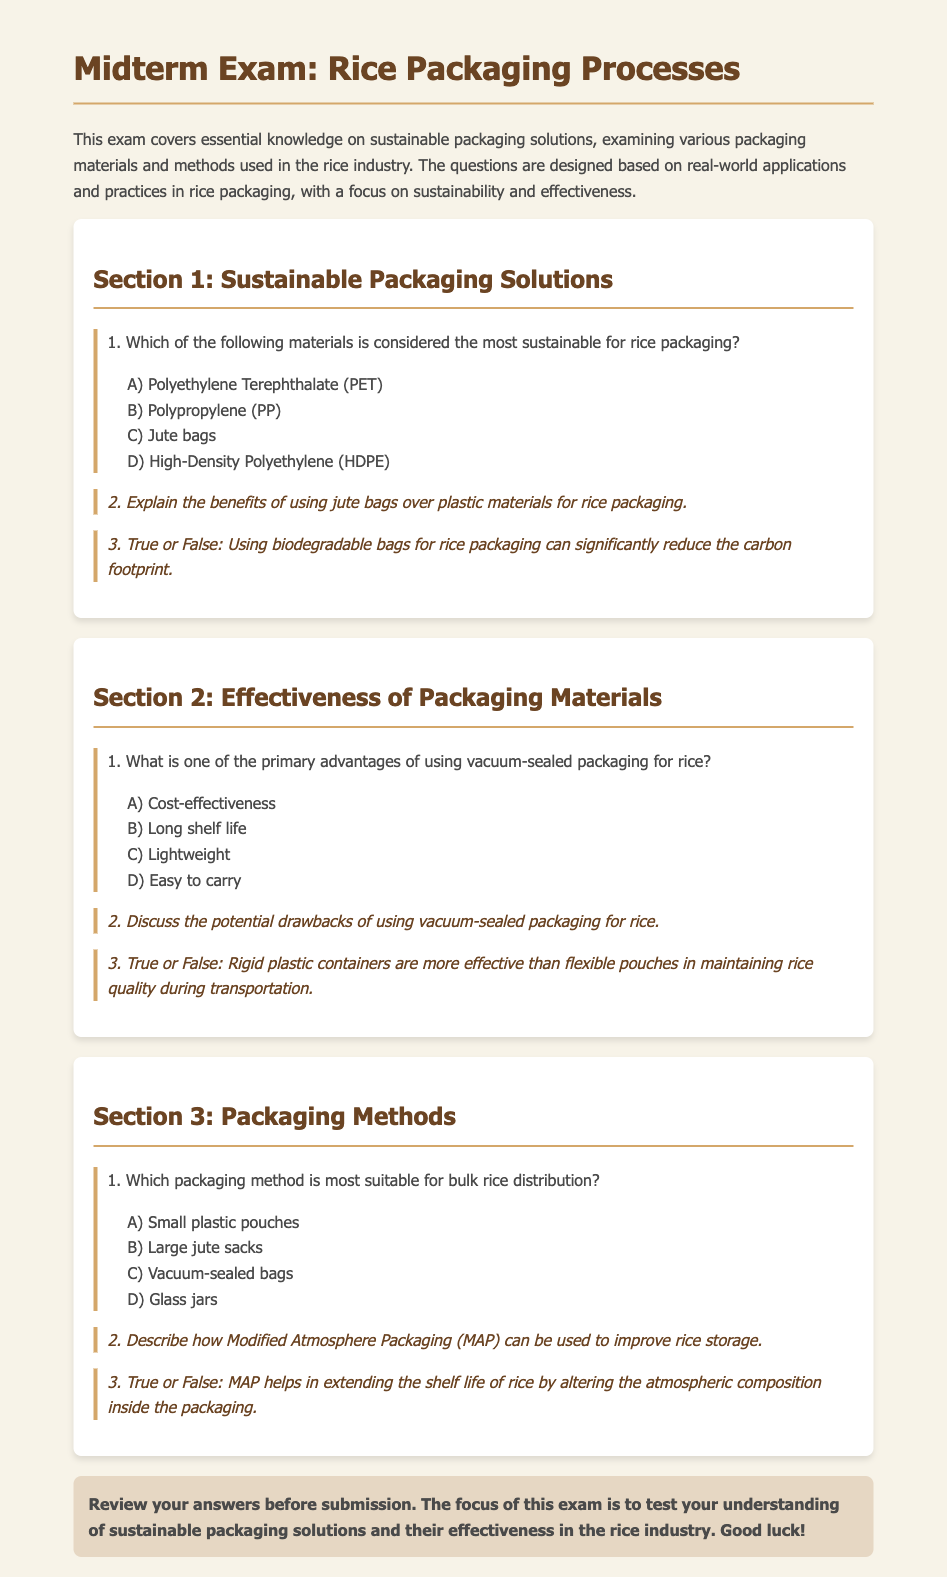What is the title of the exam? The title is found in the heading of the document, specifically stated as "Midterm Exam: Rice Packaging Processes."
Answer: Midterm Exam: Rice Packaging Processes What materials are considered for rice packaging in Section 1? The materials listed for consideration in Section 1 are found in question 1 and include options A) PET, B) PP, C) Jute bags, and D) HDPE.
Answer: PET, PP, Jute bags, HDPE What is the correct answer for the sustainable packaging material question in Section 1? The correct answer option for the sustainable packaging material is specified and is C) Jute bags.
Answer: Jute bags What method is identified for bulk rice distribution in Section 3? The method suitable for bulk rice distribution is indicated in question 1 of Section 3, and the correct option is B) Large jute sacks.
Answer: Large jute sacks What is a benefit of using jute bags over plastics? The response requires a short explanation found in question 2 of Section 1, discussing environmental benefits and biodegradability.
Answer: Environmental benefits What does MAP stand for? The acronym MAP is mentioned in question 2 of Section 3, which refers to Modified Atmosphere Packaging.
Answer: Modified Atmosphere Packaging How does vacuum-sealed packaging affect rice shelf life? It is a primary advantage mentioned in question 1 of Section 2, specifying increased longevity of rice.
Answer: Long shelf life Is using biodegradable bags effective in reducing carbon footprint? This is a true-false statement in question 3 of Section 1, indicating the effectiveness of biodegradable bags.
Answer: True What is the potential drawback of vacuum-sealed packaging? The question in Section 2, question 2 requires a discussion of the drawbacks, leading to considerations such as cost or complexity.
Answer: Cost or complexity Does MAP extend the shelf life of rice? This question is answered as a true-false statement in Section 3, question 3 affirming the impact of MAP.
Answer: True 